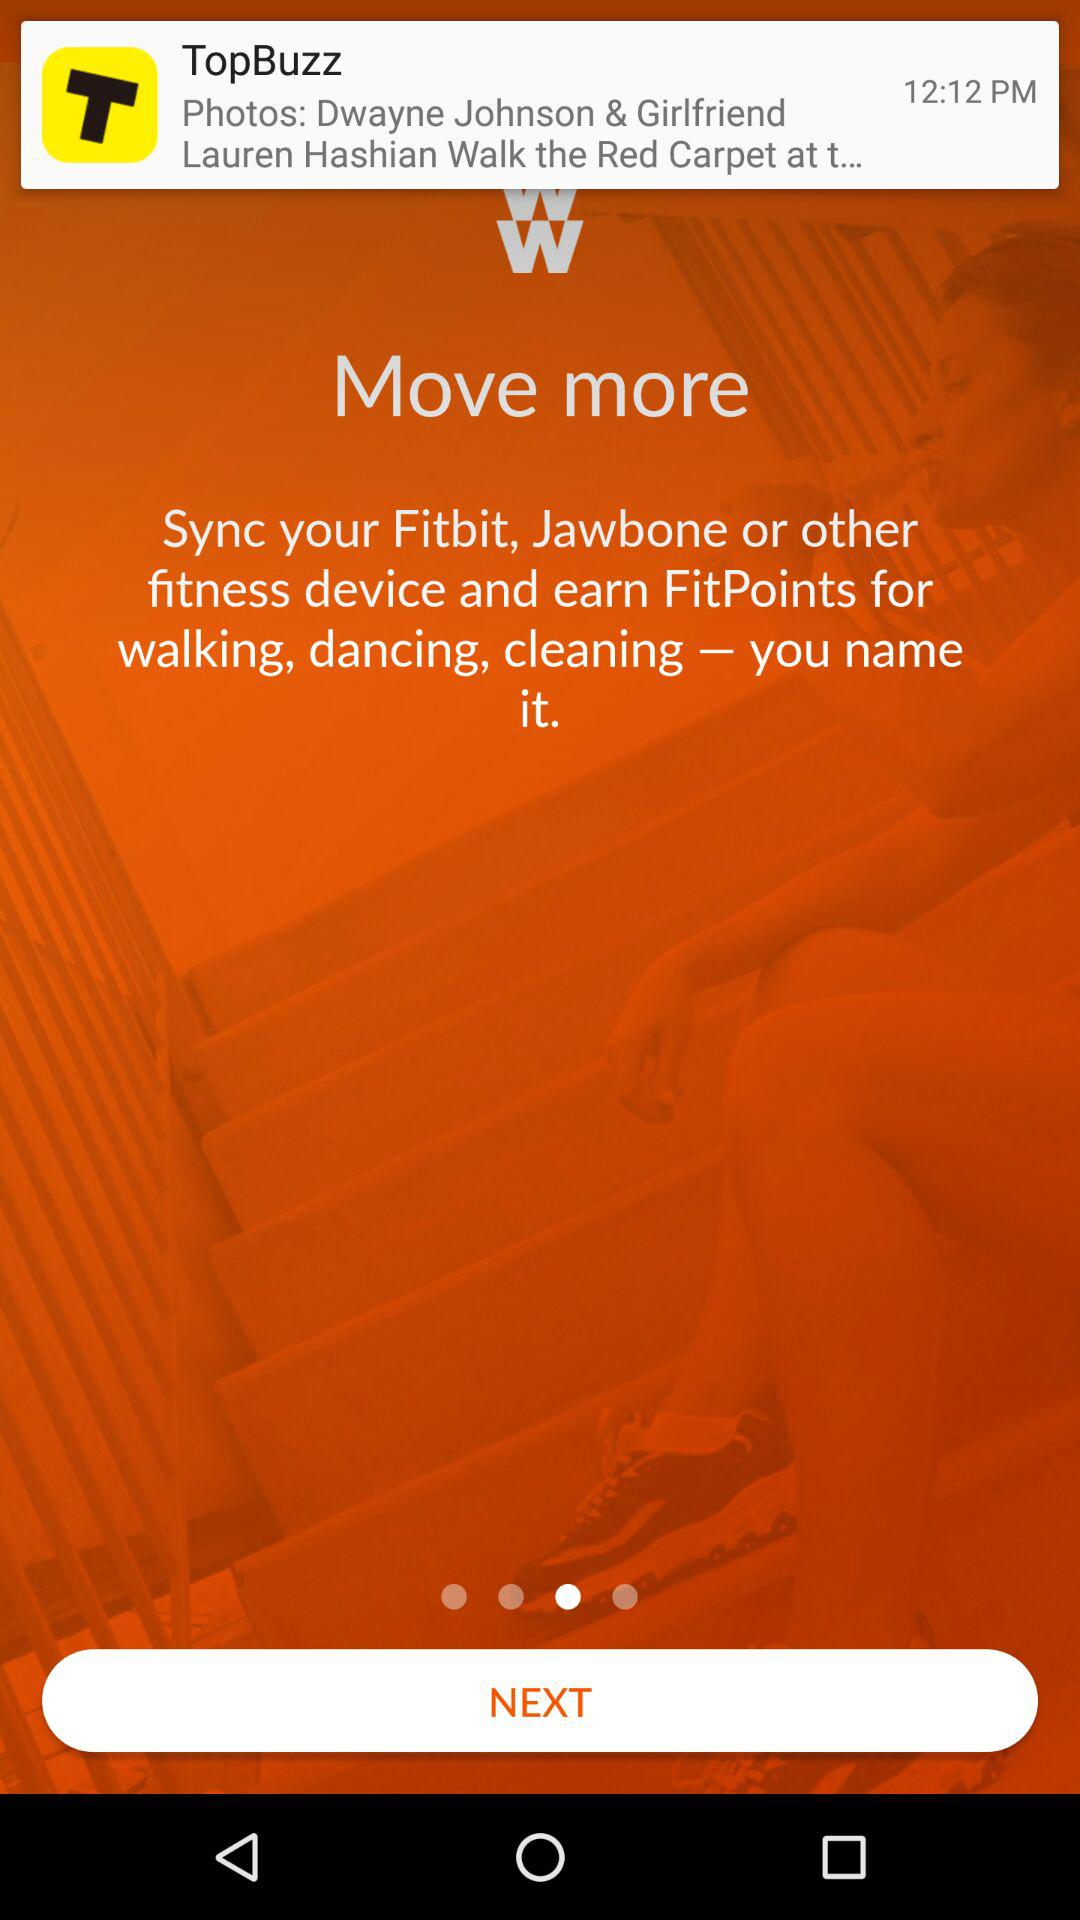At what time was the notification from "TopBuzz" received? The notification from "TopBuzz" was received at 12:12 PM. 